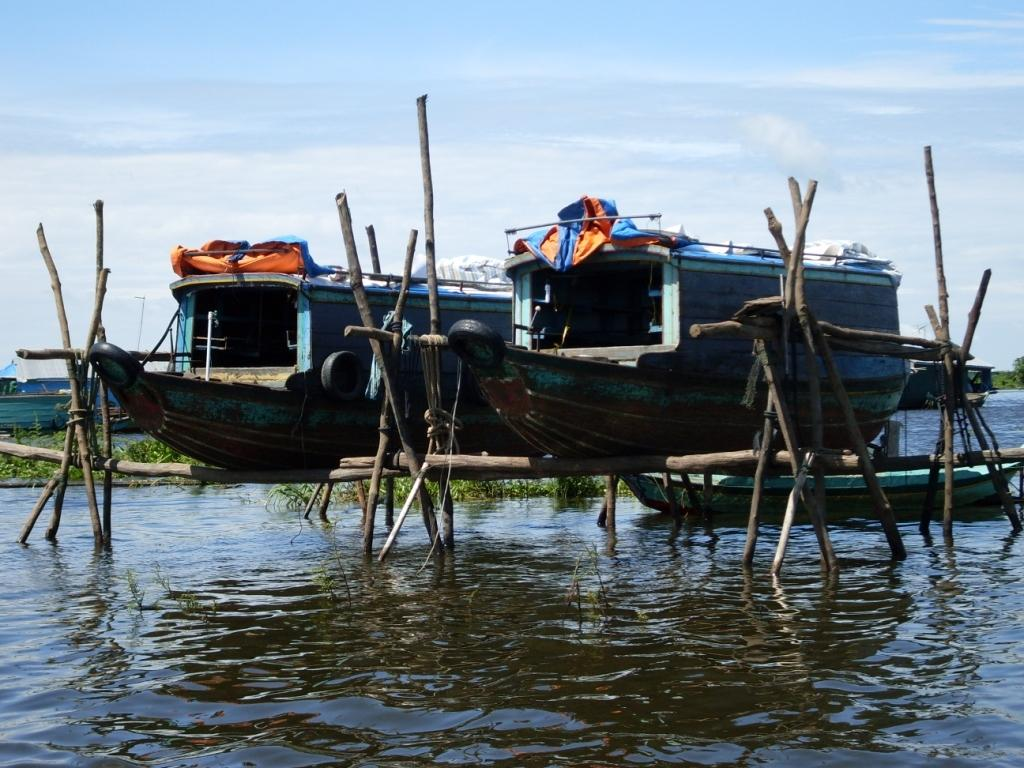What is the main subject of the image? There is a boat on water in the image. Can you describe the other boats in the image? There are two boats on sticks in the image. What type of natural environment is visible in the image? There are trees visible in the image. What is the condition of the sky in the image? There is a sky with clouds visible in the image. What type of bed can be seen in the image? There is no bed present in the image; it features boats on water and trees. What type of expansion is occurring in the image? There is no expansion occurring in the image; it is a static scene featuring boats and trees. 